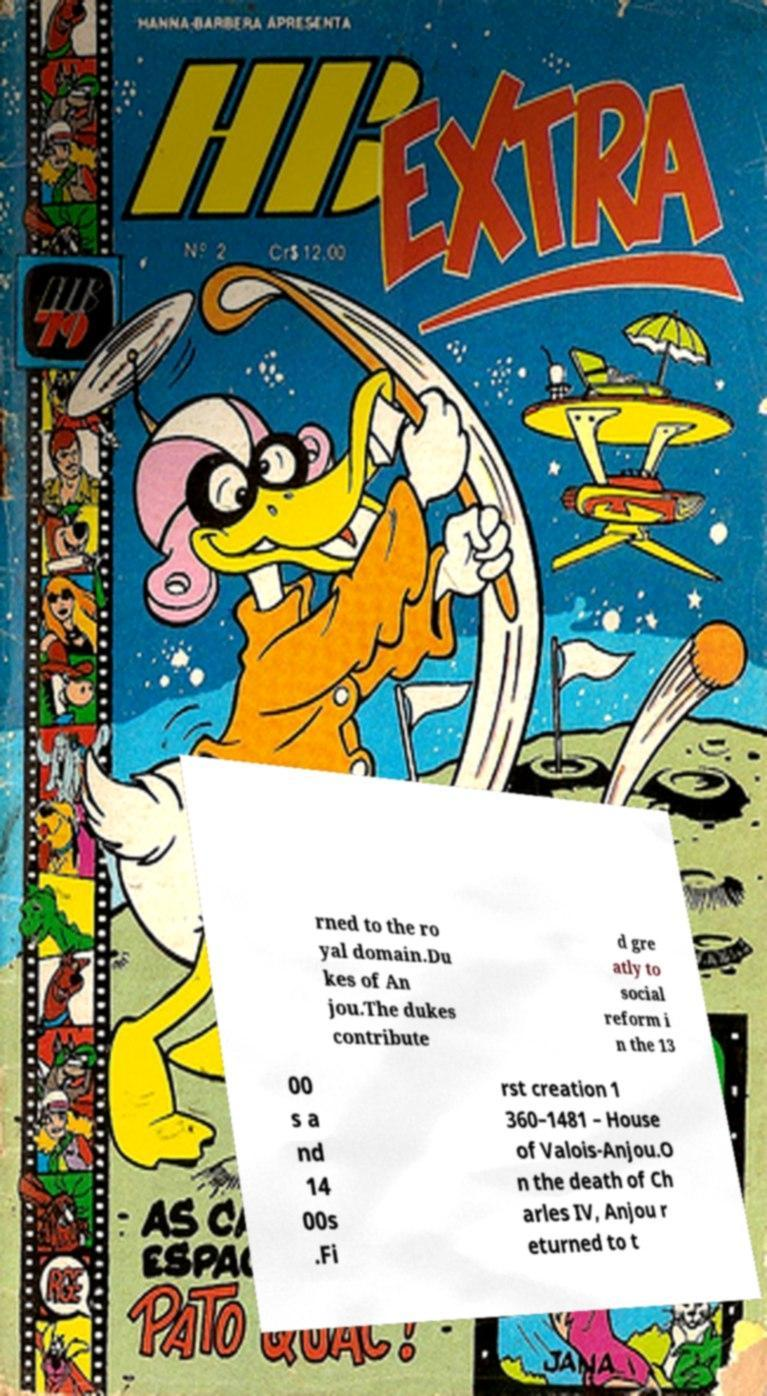Could you assist in decoding the text presented in this image and type it out clearly? rned to the ro yal domain.Du kes of An jou.The dukes contribute d gre atly to social reform i n the 13 00 s a nd 14 00s .Fi rst creation 1 360–1481 – House of Valois-Anjou.O n the death of Ch arles IV, Anjou r eturned to t 